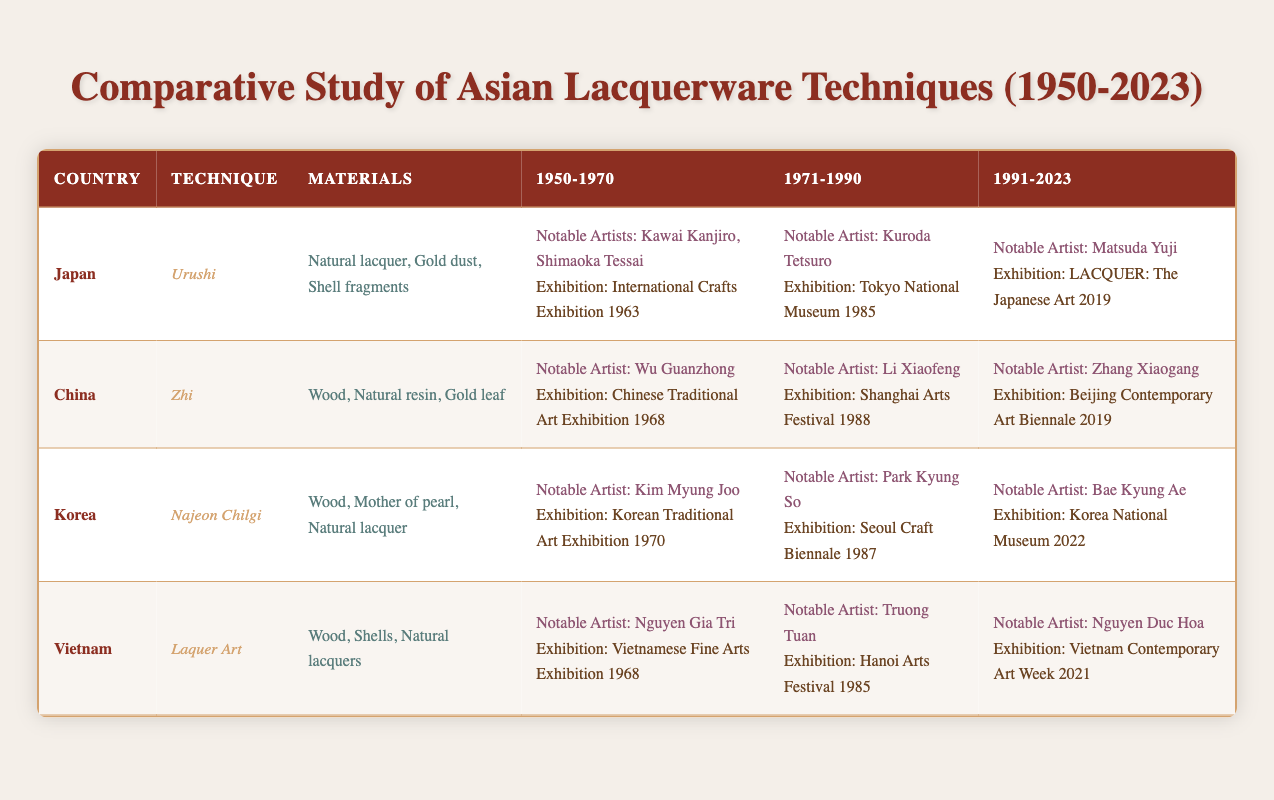What lacquerware technique is used in Japan? According to the table, the technique used in Japan is Urushi.
Answer: Urushi Which notable artist represented Japan in the period of 1971-1990? The table states that Kuroda Tetsuro was a notable artist representing Japan in that period.
Answer: Kuroda Tetsuro Which country utilizes natural resins in its lacquerware technique? The table shows that China uses natural resin in its Zhi technique.
Answer: China True or False: The notable artist for Vietnam from 1991 to 2023 is Nguyen Gia Tri. The table indicates that Nguyen Gia Tri is the notable artist for the period of 1950-1970, not 1991-2023, making this statement false.
Answer: False How many different countries are represented in this table? The table lists four countries: Japan, China, Korea, and Vietnam, which sums up to four different countries.
Answer: 4 What was the notable artist for Korea during 1991-2023, and what was the highlighted exhibition? The table mentions that Bae Kyung Ae was the notable artist for Korea, with the highlighted exhibition being Korea National Museum 2022.
Answer: Bae Kyung Ae; Korea National Museum 2022 Which technique developed in Vietnam uses shells as part of its materials? The table specifies that the Laquer Art technique in Vietnam includes shells as part of its materials.
Answer: Laquer Art Comparing the techniques, how many unique materials does the Najeon Chilgi technique have? According to the table, the Najeon Chilgi technique from Korea includes three unique materials: wood, mother of pearl, and natural lacquer.
Answer: 3 True or False: The Chinese lacquer technique has an exhibition highlight from the 1980s. The table indicates that the Zhi technique has an exhibition highlight from the Shanghai Arts Festival in 1988, confirming the statement as true.
Answer: True 